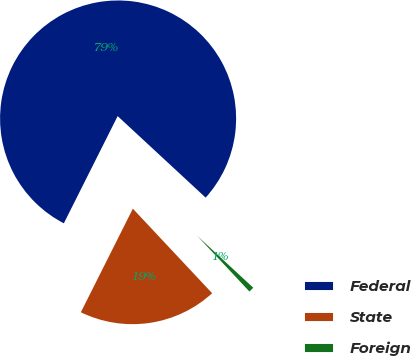Convert chart to OTSL. <chart><loc_0><loc_0><loc_500><loc_500><pie_chart><fcel>Federal<fcel>State<fcel>Foreign<nl><fcel>79.48%<fcel>19.39%<fcel>1.12%<nl></chart> 